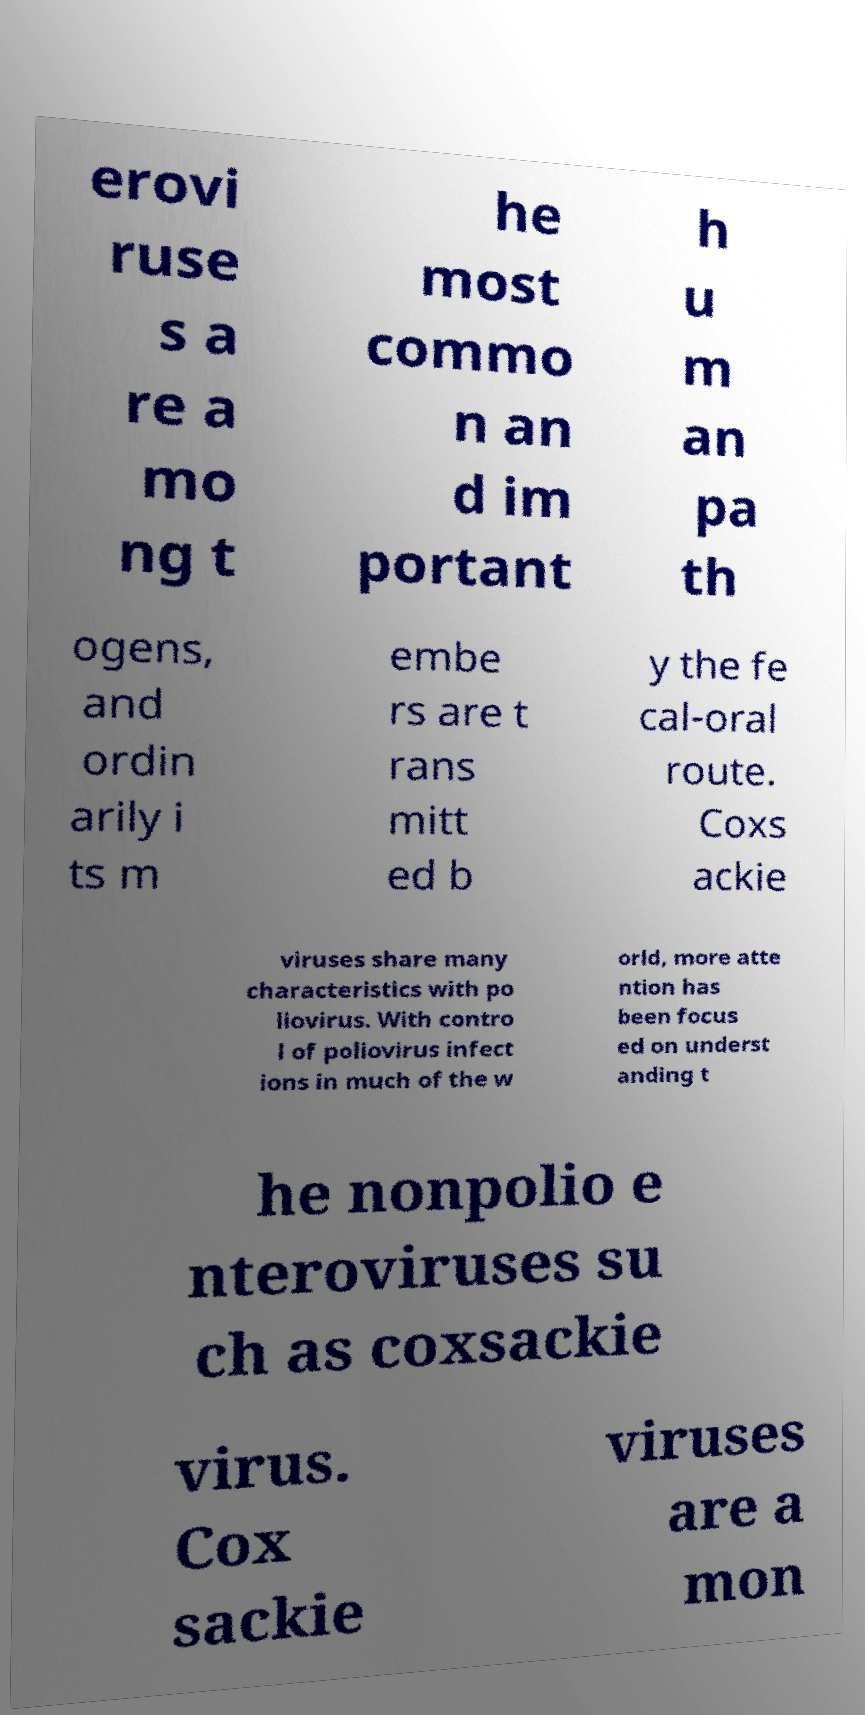Can you accurately transcribe the text from the provided image for me? erovi ruse s a re a mo ng t he most commo n an d im portant h u m an pa th ogens, and ordin arily i ts m embe rs are t rans mitt ed b y the fe cal-oral route. Coxs ackie viruses share many characteristics with po liovirus. With contro l of poliovirus infect ions in much of the w orld, more atte ntion has been focus ed on underst anding t he nonpolio e nteroviruses su ch as coxsackie virus. Cox sackie viruses are a mon 